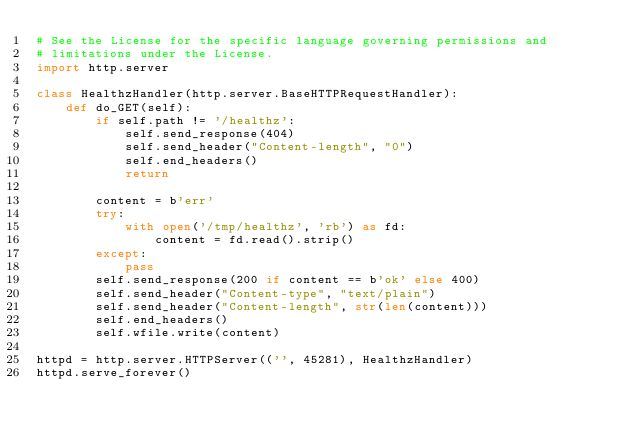Convert code to text. <code><loc_0><loc_0><loc_500><loc_500><_Python_># See the License for the specific language governing permissions and
# limitations under the License.
import http.server

class HealthzHandler(http.server.BaseHTTPRequestHandler):
    def do_GET(self):
        if self.path != '/healthz':
            self.send_response(404)
            self.send_header("Content-length", "0")
            self.end_headers()
            return

        content = b'err'
        try:
            with open('/tmp/healthz', 'rb') as fd:
                content = fd.read().strip()
        except:
            pass
        self.send_response(200 if content == b'ok' else 400)
        self.send_header("Content-type", "text/plain")
        self.send_header("Content-length", str(len(content)))
        self.end_headers()
        self.wfile.write(content)

httpd = http.server.HTTPServer(('', 45281), HealthzHandler)
httpd.serve_forever()
</code> 